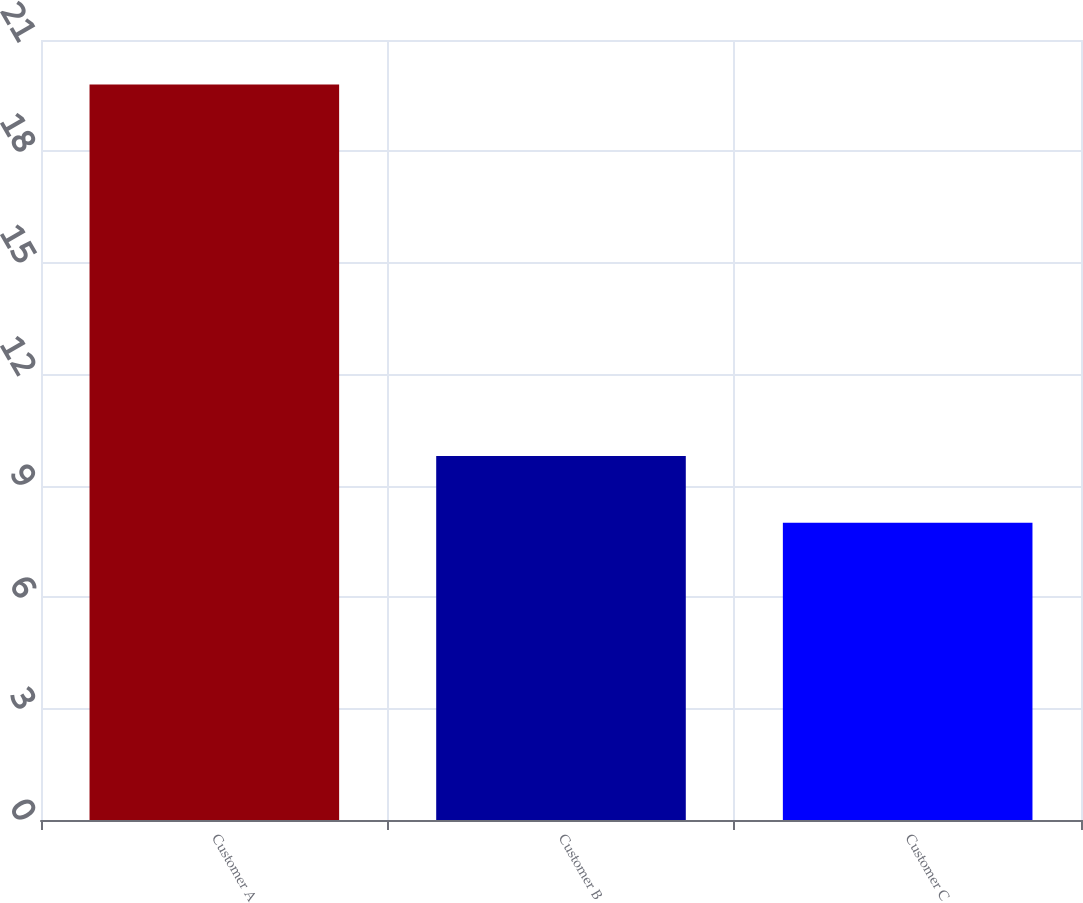<chart> <loc_0><loc_0><loc_500><loc_500><bar_chart><fcel>Customer A<fcel>Customer B<fcel>Customer C<nl><fcel>19.8<fcel>9.8<fcel>8<nl></chart> 